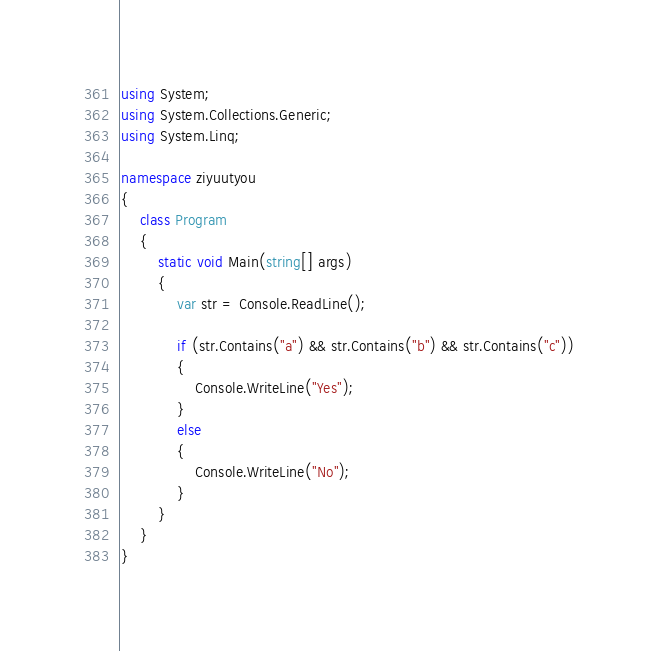<code> <loc_0><loc_0><loc_500><loc_500><_C#_>using System;
using System.Collections.Generic;
using System.Linq;

namespace ziyuutyou
{
    class Program
    {
        static void Main(string[] args)
        {
            var str = Console.ReadLine();

            if (str.Contains("a") && str.Contains("b") && str.Contains("c"))
            {
                Console.WriteLine("Yes");
            }
            else
            {
                Console.WriteLine("No");
            }
        }
    }
}
</code> 